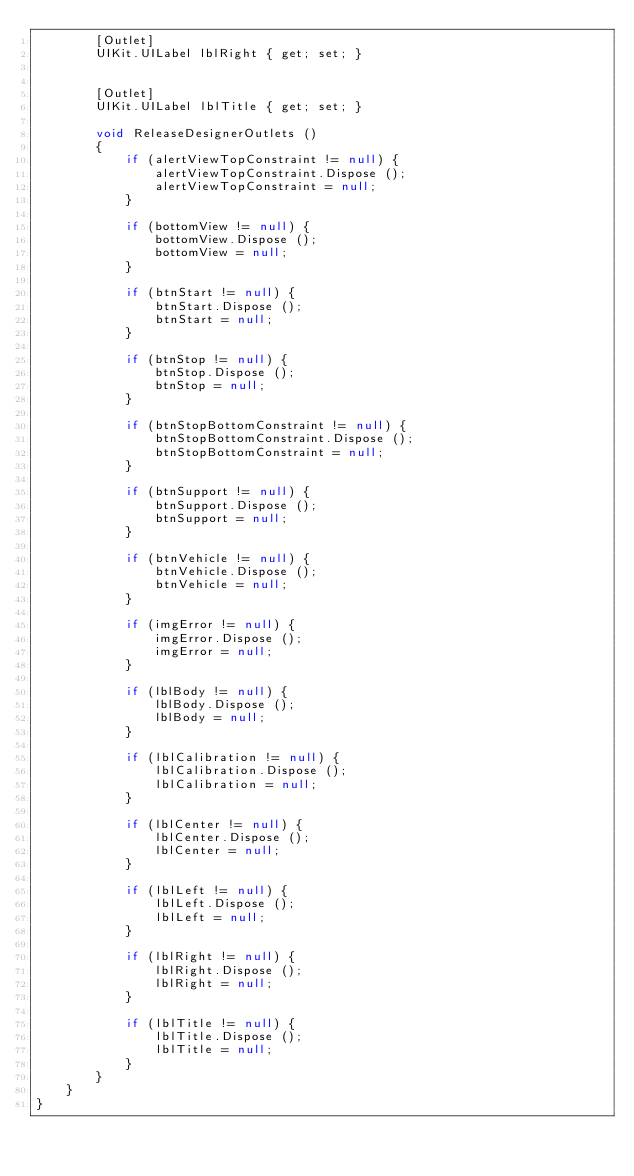Convert code to text. <code><loc_0><loc_0><loc_500><loc_500><_C#_>        [Outlet]
        UIKit.UILabel lblRight { get; set; }


        [Outlet]
        UIKit.UILabel lblTitle { get; set; }

        void ReleaseDesignerOutlets ()
        {
            if (alertViewTopConstraint != null) {
                alertViewTopConstraint.Dispose ();
                alertViewTopConstraint = null;
            }

            if (bottomView != null) {
                bottomView.Dispose ();
                bottomView = null;
            }

            if (btnStart != null) {
                btnStart.Dispose ();
                btnStart = null;
            }

            if (btnStop != null) {
                btnStop.Dispose ();
                btnStop = null;
            }

            if (btnStopBottomConstraint != null) {
                btnStopBottomConstraint.Dispose ();
                btnStopBottomConstraint = null;
            }

            if (btnSupport != null) {
                btnSupport.Dispose ();
                btnSupport = null;
            }

            if (btnVehicle != null) {
                btnVehicle.Dispose ();
                btnVehicle = null;
            }

            if (imgError != null) {
                imgError.Dispose ();
                imgError = null;
            }

            if (lblBody != null) {
                lblBody.Dispose ();
                lblBody = null;
            }

            if (lblCalibration != null) {
                lblCalibration.Dispose ();
                lblCalibration = null;
            }

            if (lblCenter != null) {
                lblCenter.Dispose ();
                lblCenter = null;
            }

            if (lblLeft != null) {
                lblLeft.Dispose ();
                lblLeft = null;
            }

            if (lblRight != null) {
                lblRight.Dispose ();
                lblRight = null;
            }

            if (lblTitle != null) {
                lblTitle.Dispose ();
                lblTitle = null;
            }
        }
    }
}</code> 